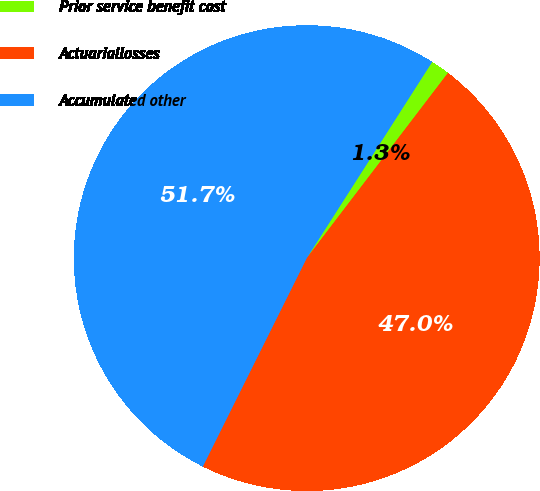<chart> <loc_0><loc_0><loc_500><loc_500><pie_chart><fcel>Prior service benefit cost<fcel>Actuariallosses<fcel>Accumulated other<nl><fcel>1.32%<fcel>46.99%<fcel>51.69%<nl></chart> 